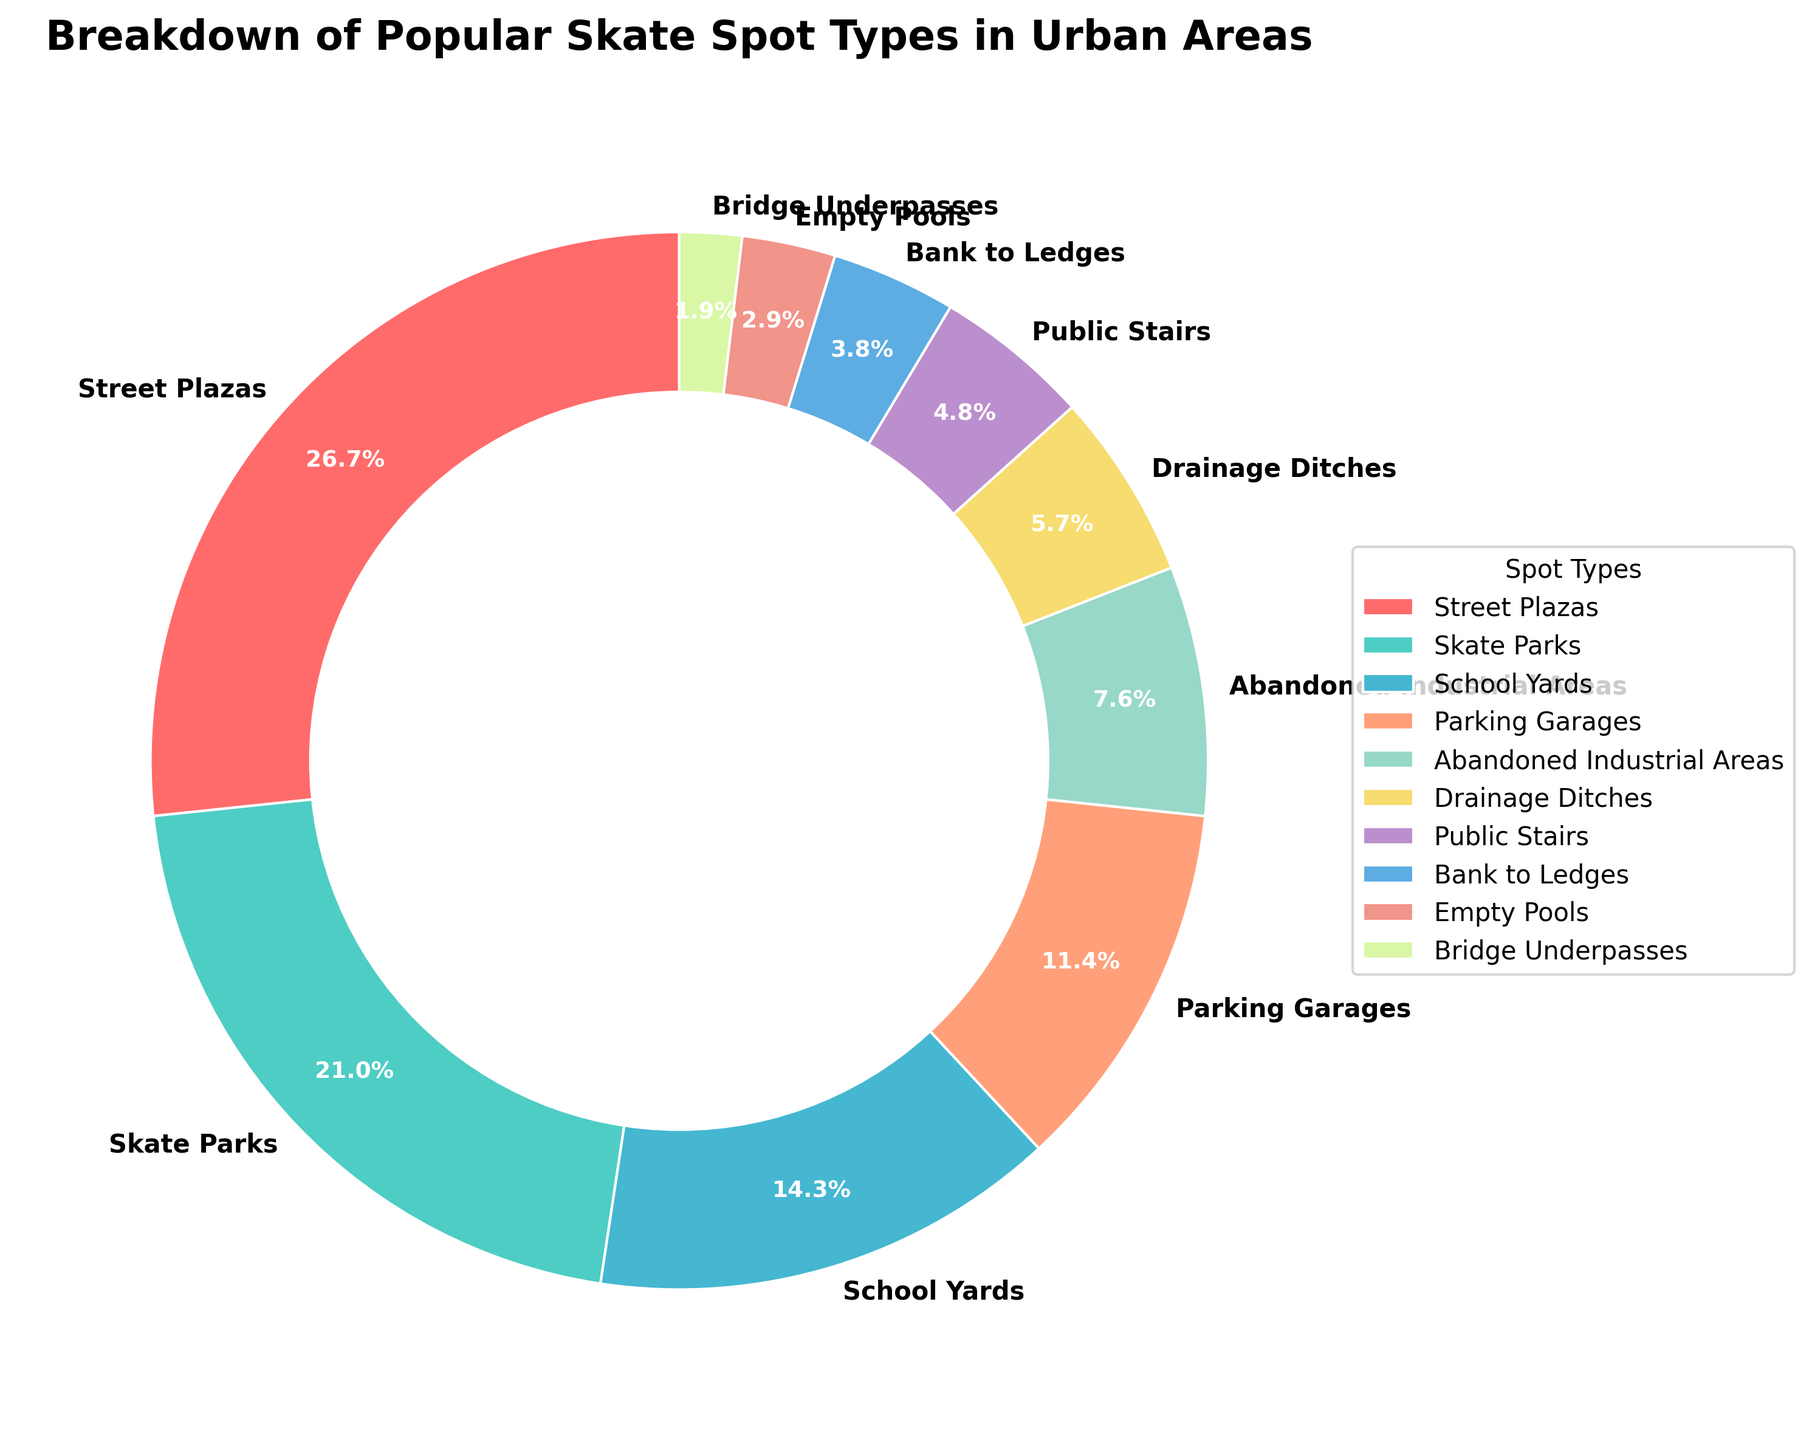What percentage of skate spots in urban areas are street plazas? The pie chart shows that street plazas occupy 28% of the total skate spots in urban areas.
Answer: 28% Which two skate spot types together account for more than 40% of the total spots? Street plazas and skate parks together account for more than 40%: 28% + 22% = 50%.
Answer: Street plazas and skate parks Are there more skate parks or school yards as skate spots in urban areas? The pie chart depicts that skate parks account for 22% while school yards account for 15%. Therefore, skate parks are more prevalent.
Answer: Skate parks Which skate spot type is the least popular? According to the chart, bridge underpasses are the least popular with 2%.
Answer: Bridge underpasses What is the combined percentage of parking garages and public stairs? Parking garages make up 12% and public stairs 5%, so combined it's 12% + 5% = 17%.
Answer: 17% What are the top three most popular skate spot types? The top three most popular spot types, based on percentage, are street plazas (28%), skate parks (22%), and school yards (15%).
Answer: Street plazas, skate parks, school yards How many spot types have a percentage less than 10%? The spot types with less than 10% are abandoned industrial areas (8%), drainage ditches (6%), public stairs (5%), bank to ledges (4%), empty pools (3%), and bridge underpasses (2%). There are 6 such types.
Answer: 6 Which spot type is represented by a color similar to light blue? The color light blue on the chart represents skate parks.
Answer: Skate parks Is the percentage of empty pools greater than or less than that of public stairs? The chart shows that empty pools account for 3% while public stairs account for 5%. So, empty pools have a lower percentage.
Answer: Less What is the difference in percentage between bank to ledges and public stairs? Bank to ledges account for 4% and public stairs for 5%, making the difference 5% - 4% = 1%.
Answer: 1% 